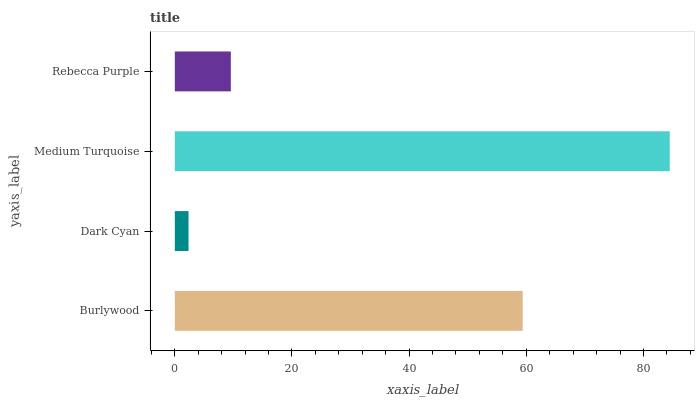Is Dark Cyan the minimum?
Answer yes or no. Yes. Is Medium Turquoise the maximum?
Answer yes or no. Yes. Is Medium Turquoise the minimum?
Answer yes or no. No. Is Dark Cyan the maximum?
Answer yes or no. No. Is Medium Turquoise greater than Dark Cyan?
Answer yes or no. Yes. Is Dark Cyan less than Medium Turquoise?
Answer yes or no. Yes. Is Dark Cyan greater than Medium Turquoise?
Answer yes or no. No. Is Medium Turquoise less than Dark Cyan?
Answer yes or no. No. Is Burlywood the high median?
Answer yes or no. Yes. Is Rebecca Purple the low median?
Answer yes or no. Yes. Is Medium Turquoise the high median?
Answer yes or no. No. Is Dark Cyan the low median?
Answer yes or no. No. 